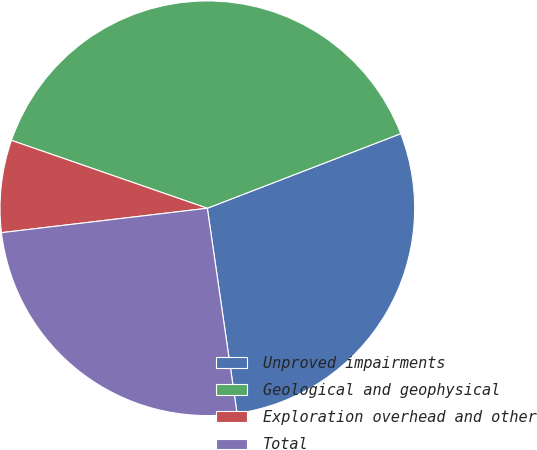Convert chart. <chart><loc_0><loc_0><loc_500><loc_500><pie_chart><fcel>Unproved impairments<fcel>Geological and geophysical<fcel>Exploration overhead and other<fcel>Total<nl><fcel>28.57%<fcel>38.83%<fcel>7.19%<fcel>25.41%<nl></chart> 